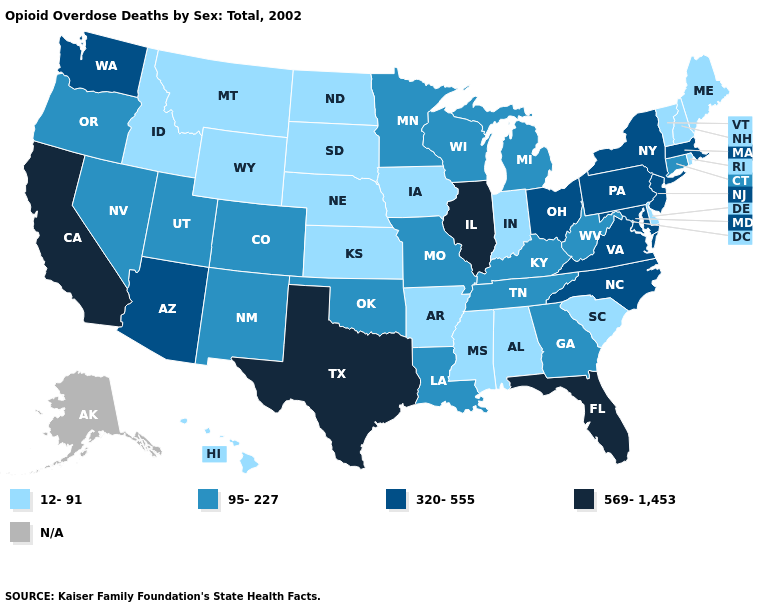Name the states that have a value in the range 320-555?
Answer briefly. Arizona, Maryland, Massachusetts, New Jersey, New York, North Carolina, Ohio, Pennsylvania, Virginia, Washington. Is the legend a continuous bar?
Keep it brief. No. What is the value of South Carolina?
Concise answer only. 12-91. What is the highest value in the USA?
Short answer required. 569-1,453. What is the value of Maine?
Short answer required. 12-91. Name the states that have a value in the range N/A?
Write a very short answer. Alaska. What is the highest value in states that border Georgia?
Concise answer only. 569-1,453. Which states have the lowest value in the South?
Quick response, please. Alabama, Arkansas, Delaware, Mississippi, South Carolina. What is the value of Missouri?
Give a very brief answer. 95-227. Among the states that border Arkansas , which have the highest value?
Answer briefly. Texas. What is the lowest value in states that border Massachusetts?
Answer briefly. 12-91. 